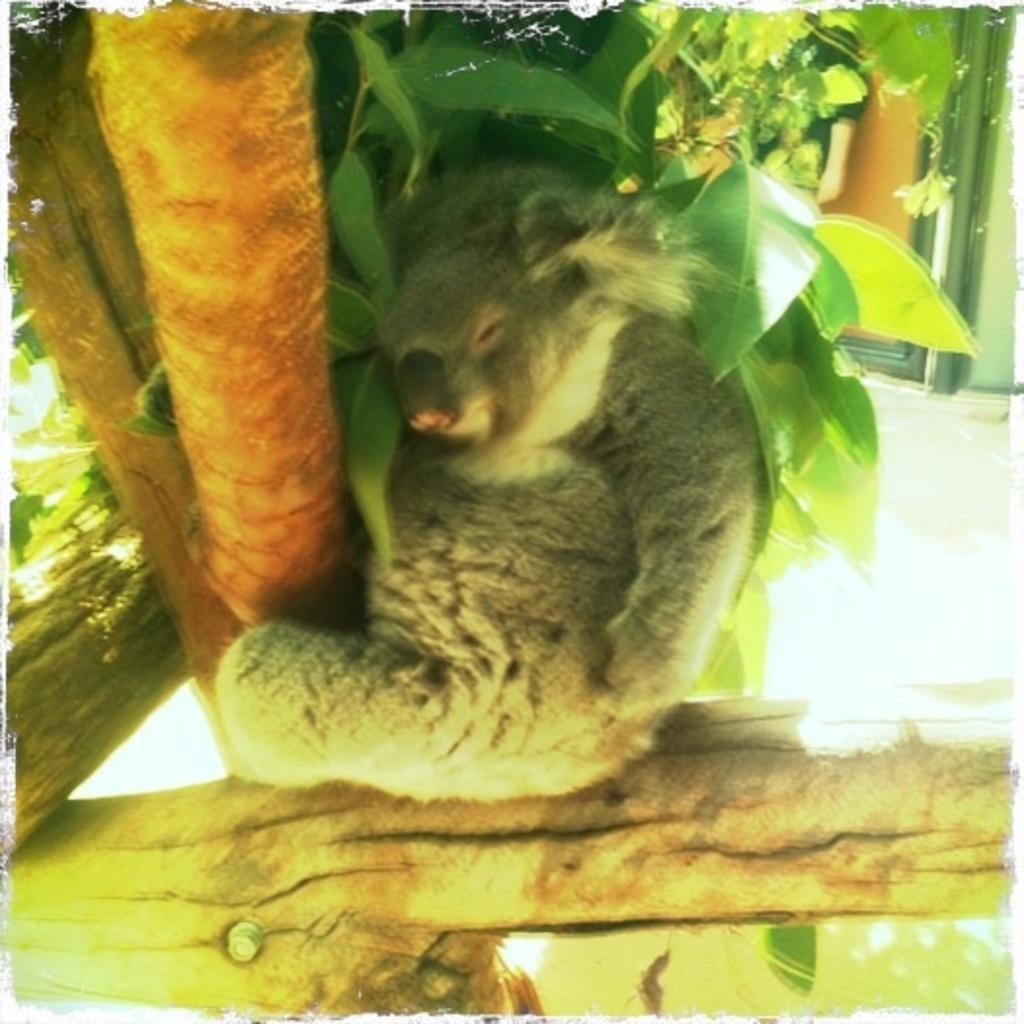Describe this image in one or two sentences. This image consists of an animal. And we can see a tree. In the background, it looks like a door and a wall. At the bottom, there is a floor. 